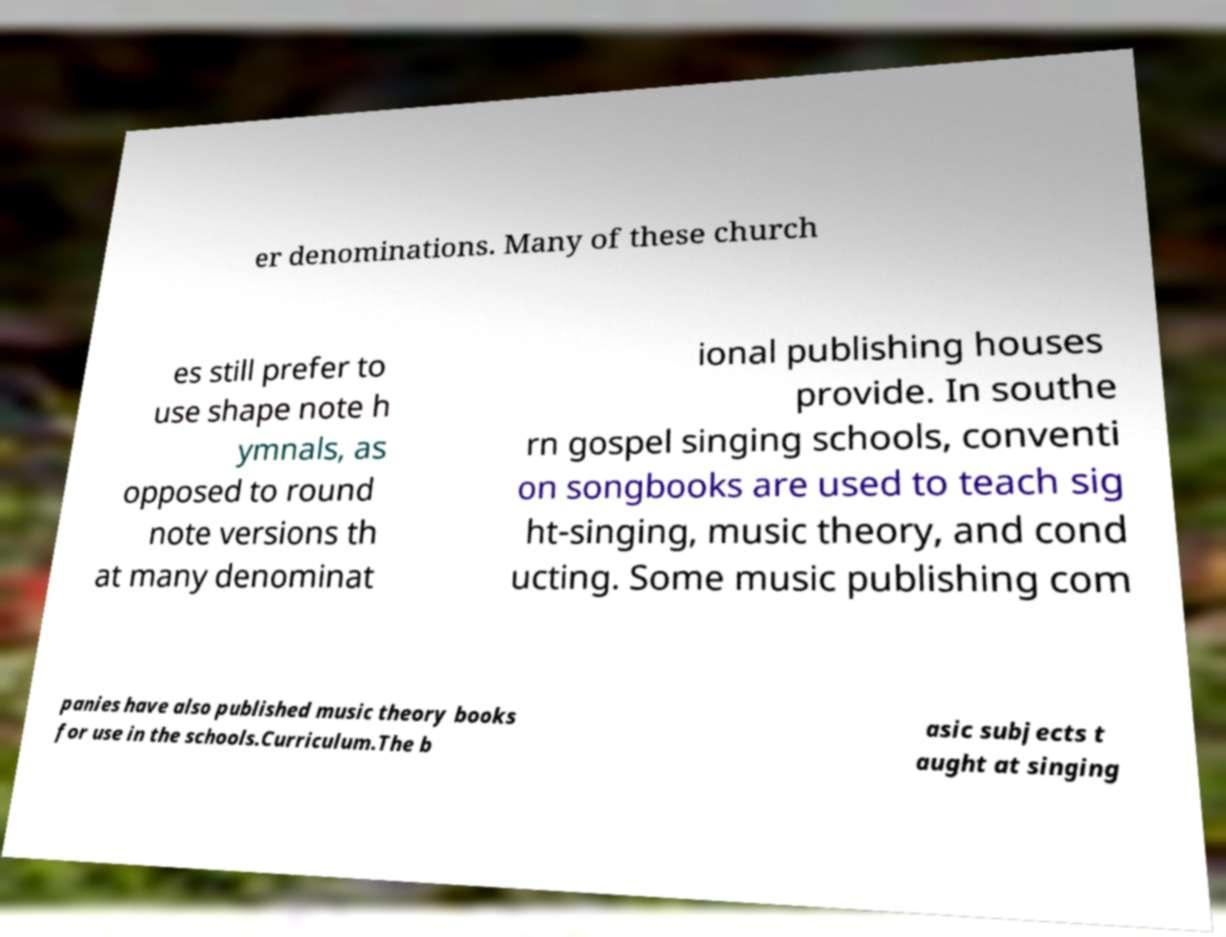What messages or text are displayed in this image? I need them in a readable, typed format. er denominations. Many of these church es still prefer to use shape note h ymnals, as opposed to round note versions th at many denominat ional publishing houses provide. In southe rn gospel singing schools, conventi on songbooks are used to teach sig ht-singing, music theory, and cond ucting. Some music publishing com panies have also published music theory books for use in the schools.Curriculum.The b asic subjects t aught at singing 